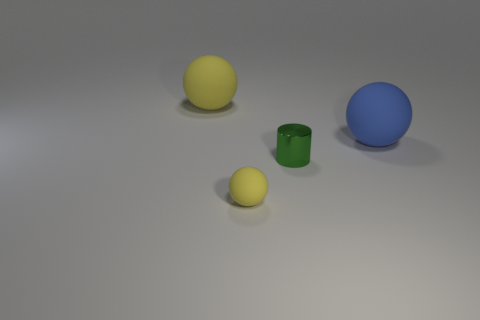Are the small yellow sphere and the small cylinder that is in front of the large blue matte ball made of the same material?
Ensure brevity in your answer.  No. The tiny ball has what color?
Your response must be concise. Yellow. The green thing right of the big yellow rubber thing has what shape?
Make the answer very short. Cylinder. How many yellow objects are matte things or large objects?
Your answer should be very brief. 2. There is a large object that is the same material as the large yellow ball; what color is it?
Your response must be concise. Blue. There is a small matte sphere; is its color the same as the big rubber thing on the right side of the large yellow rubber object?
Provide a succinct answer. No. There is a matte ball that is behind the small metallic thing and on the left side of the big blue matte sphere; what color is it?
Provide a succinct answer. Yellow. There is a tiny green cylinder; how many tiny matte balls are behind it?
Your answer should be compact. 0. How many objects are either large blue things or yellow matte spheres in front of the big yellow sphere?
Provide a short and direct response. 2. There is a yellow matte ball that is behind the green thing; is there a small rubber thing behind it?
Your answer should be very brief. No. 